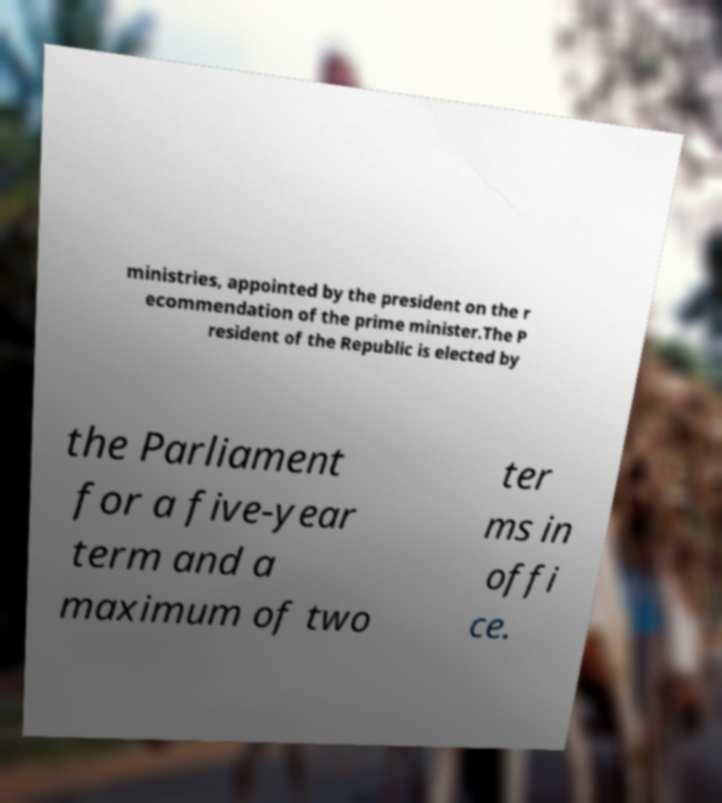Can you read and provide the text displayed in the image?This photo seems to have some interesting text. Can you extract and type it out for me? ministries, appointed by the president on the r ecommendation of the prime minister.The P resident of the Republic is elected by the Parliament for a five-year term and a maximum of two ter ms in offi ce. 